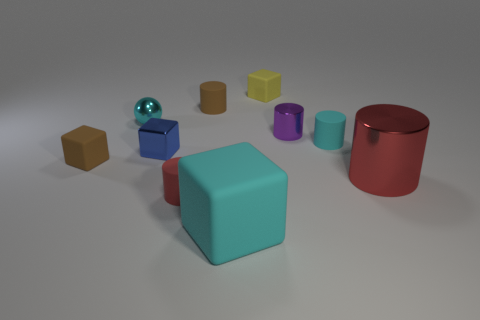Are there any other things that are the same shape as the tiny cyan metal object?
Keep it short and to the point. No. What is the shape of the small brown thing that is on the right side of the small red thing?
Your answer should be very brief. Cylinder. Is the red rubber object the same shape as the small purple metal thing?
Keep it short and to the point. Yes. What is the size of the cyan matte object that is the same shape as the small yellow thing?
Your answer should be very brief. Large. There is a brown matte thing in front of the metallic sphere; is it the same size as the big block?
Provide a succinct answer. No. How big is the matte cube that is both in front of the small brown cylinder and right of the tiny blue object?
Offer a terse response. Large. What is the material of the thing that is the same color as the big metallic cylinder?
Offer a terse response. Rubber. How many matte cylinders are the same color as the big shiny object?
Your answer should be very brief. 1. Is the number of yellow rubber blocks on the left side of the yellow cube the same as the number of cyan spheres?
Your answer should be very brief. No. The tiny metallic cylinder has what color?
Offer a terse response. Purple. 